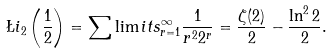<formula> <loc_0><loc_0><loc_500><loc_500>\L i _ { 2 } \left ( { { \frac { 1 } { 2 } } } \right ) = { \sum \lim i t s _ { r = 1 } ^ { \infty } { { \frac { 1 } { { r ^ { 2 } 2 ^ { r } } } } } } = { \frac { \zeta ( 2 ) } { 2 } } - { \frac { { \ln ^ { 2 } 2 } } { 2 } } .</formula> 